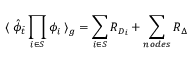Convert formula to latex. <formula><loc_0><loc_0><loc_500><loc_500>\langle \, { \hat { \phi } } _ { \bar { t } } \prod _ { i \in S } \phi _ { i } \, \rangle _ { g } = \sum _ { i \in S } R _ { D _ { i } } + \sum _ { n o d e s } R _ { \Delta } \,</formula> 